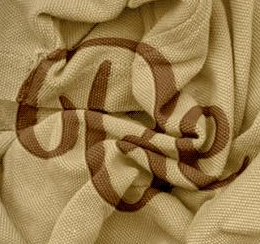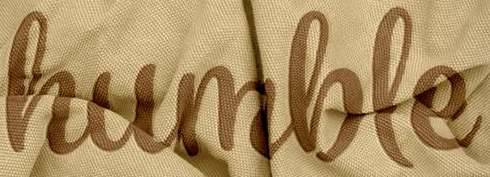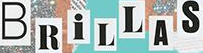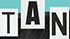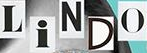Read the text from these images in sequence, separated by a semicolon. Be; humble; BRiLLAS; TAN; LiNDO 